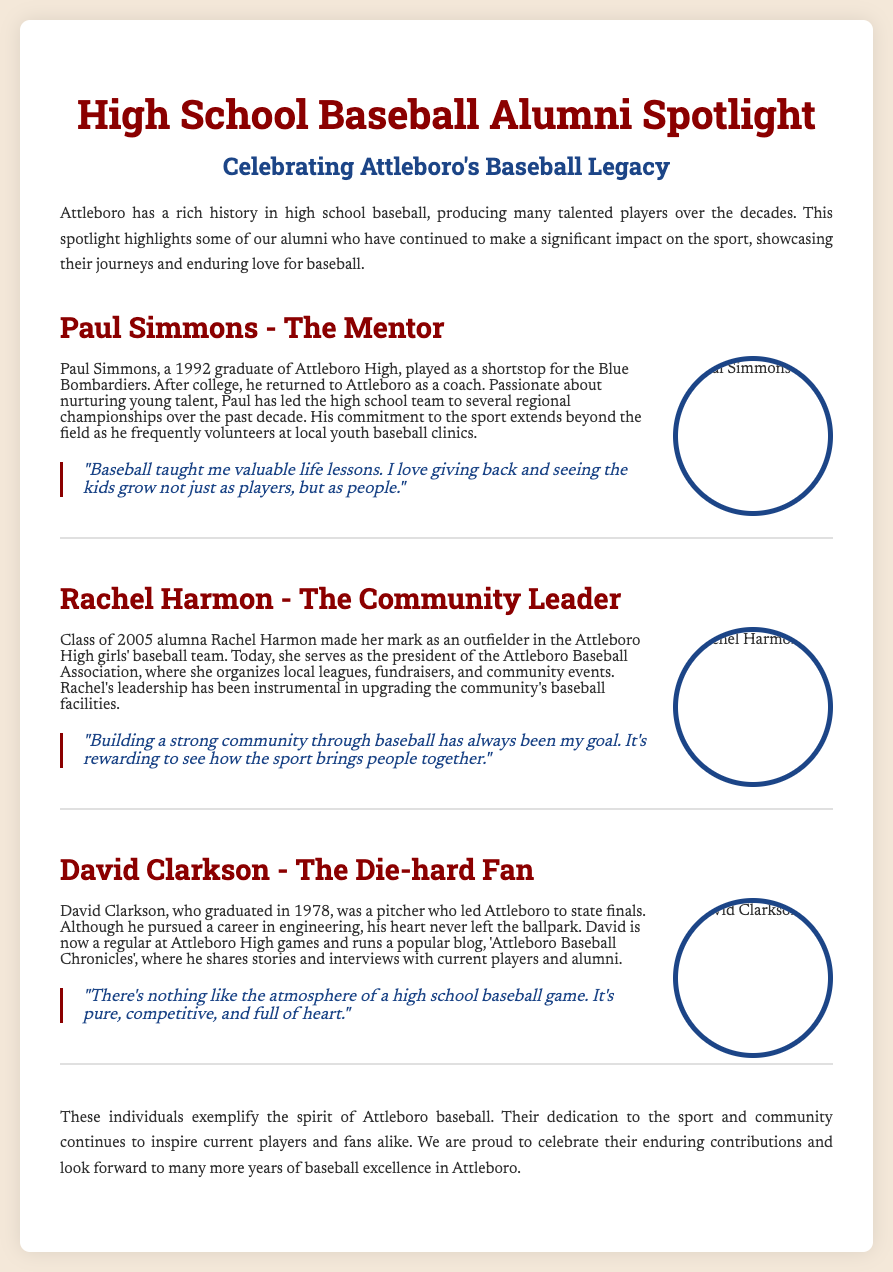What year did Paul Simmons graduate? Paul Simmons is mentioned as a 1992 graduate of Attleboro High in the document.
Answer: 1992 What role does Rachel Harmon currently hold? The document states that Rachel Harmon serves as the president of the Attleboro Baseball Association.
Answer: President Who was a pitcher that led Attleboro to state finals? David Clarkson is identified in the document as a pitcher who led Attleboro to state finals.
Answer: David Clarkson What has Rachel Harmon been instrumental in upgrading? Rachel's leadership has been important in upgrading the community's baseball facilities, as noted in the document.
Answer: Baseball facilities What is the title of David Clarkson's blog? The document includes that David Clarkson runs a blog titled 'Attleboro Baseball Chronicles'.
Answer: Attleboro Baseball Chronicles How many regional championships has Paul Simmons led the high school team to? The document states that Paul Simmons has led the high school team to several regional championships, indicating more than two but not specifying a number.
Answer: Several What does David Clarkson run? The document mentions that David Clarkson runs a popular blog.
Answer: A popular blog What is the main focus of the alumni spotlight section? The document highlights the impact of alumni on the sport, showcasing their journeys and contributions.
Answer: Contributions to the sport 